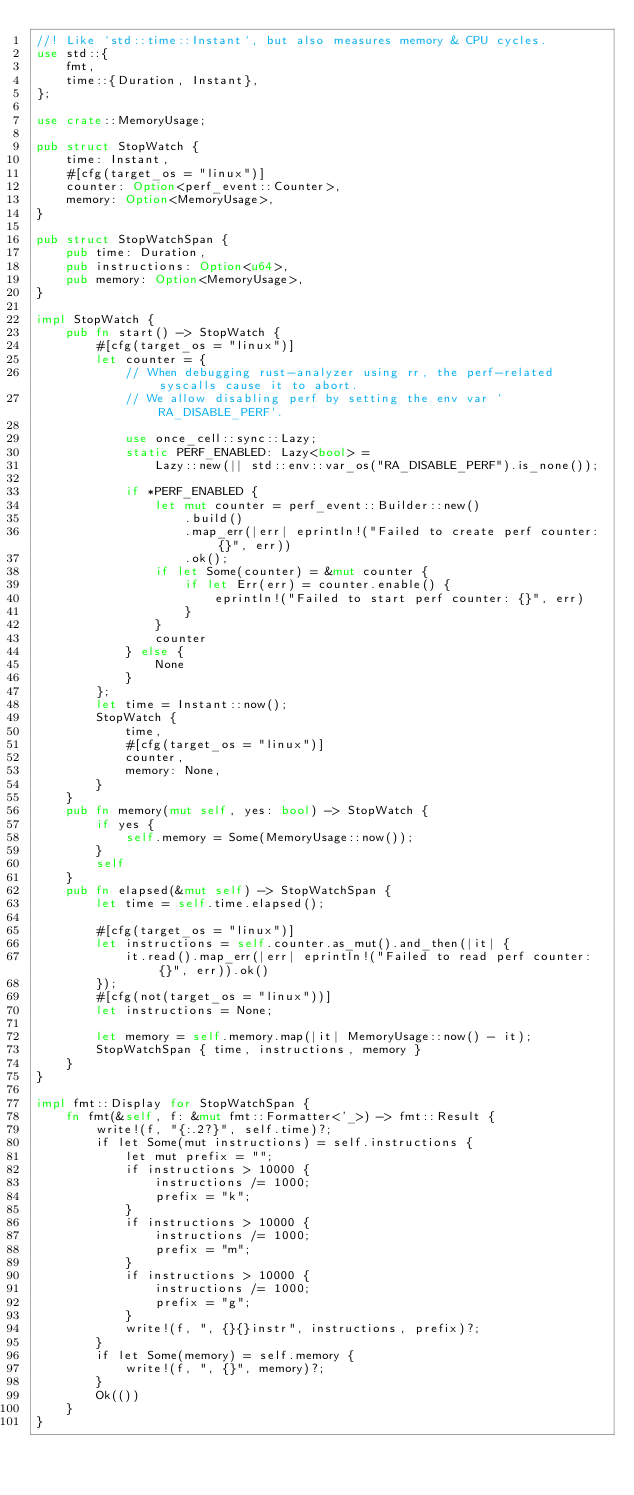Convert code to text. <code><loc_0><loc_0><loc_500><loc_500><_Rust_>//! Like `std::time::Instant`, but also measures memory & CPU cycles.
use std::{
    fmt,
    time::{Duration, Instant},
};

use crate::MemoryUsage;

pub struct StopWatch {
    time: Instant,
    #[cfg(target_os = "linux")]
    counter: Option<perf_event::Counter>,
    memory: Option<MemoryUsage>,
}

pub struct StopWatchSpan {
    pub time: Duration,
    pub instructions: Option<u64>,
    pub memory: Option<MemoryUsage>,
}

impl StopWatch {
    pub fn start() -> StopWatch {
        #[cfg(target_os = "linux")]
        let counter = {
            // When debugging rust-analyzer using rr, the perf-related syscalls cause it to abort.
            // We allow disabling perf by setting the env var `RA_DISABLE_PERF`.

            use once_cell::sync::Lazy;
            static PERF_ENABLED: Lazy<bool> =
                Lazy::new(|| std::env::var_os("RA_DISABLE_PERF").is_none());

            if *PERF_ENABLED {
                let mut counter = perf_event::Builder::new()
                    .build()
                    .map_err(|err| eprintln!("Failed to create perf counter: {}", err))
                    .ok();
                if let Some(counter) = &mut counter {
                    if let Err(err) = counter.enable() {
                        eprintln!("Failed to start perf counter: {}", err)
                    }
                }
                counter
            } else {
                None
            }
        };
        let time = Instant::now();
        StopWatch {
            time,
            #[cfg(target_os = "linux")]
            counter,
            memory: None,
        }
    }
    pub fn memory(mut self, yes: bool) -> StopWatch {
        if yes {
            self.memory = Some(MemoryUsage::now());
        }
        self
    }
    pub fn elapsed(&mut self) -> StopWatchSpan {
        let time = self.time.elapsed();

        #[cfg(target_os = "linux")]
        let instructions = self.counter.as_mut().and_then(|it| {
            it.read().map_err(|err| eprintln!("Failed to read perf counter: {}", err)).ok()
        });
        #[cfg(not(target_os = "linux"))]
        let instructions = None;

        let memory = self.memory.map(|it| MemoryUsage::now() - it);
        StopWatchSpan { time, instructions, memory }
    }
}

impl fmt::Display for StopWatchSpan {
    fn fmt(&self, f: &mut fmt::Formatter<'_>) -> fmt::Result {
        write!(f, "{:.2?}", self.time)?;
        if let Some(mut instructions) = self.instructions {
            let mut prefix = "";
            if instructions > 10000 {
                instructions /= 1000;
                prefix = "k";
            }
            if instructions > 10000 {
                instructions /= 1000;
                prefix = "m";
            }
            if instructions > 10000 {
                instructions /= 1000;
                prefix = "g";
            }
            write!(f, ", {}{}instr", instructions, prefix)?;
        }
        if let Some(memory) = self.memory {
            write!(f, ", {}", memory)?;
        }
        Ok(())
    }
}
</code> 